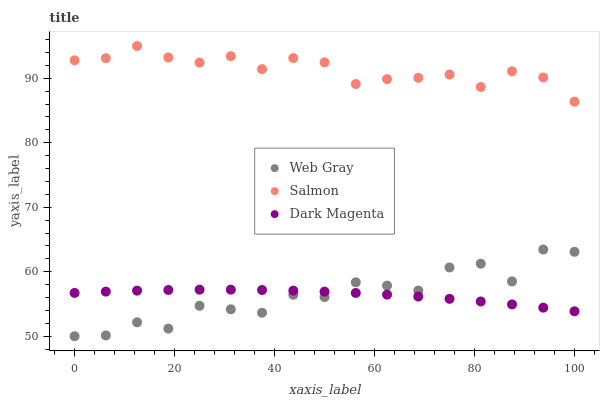Does Dark Magenta have the minimum area under the curve?
Answer yes or no. Yes. Does Salmon have the maximum area under the curve?
Answer yes or no. Yes. Does Salmon have the minimum area under the curve?
Answer yes or no. No. Does Dark Magenta have the maximum area under the curve?
Answer yes or no. No. Is Dark Magenta the smoothest?
Answer yes or no. Yes. Is Web Gray the roughest?
Answer yes or no. Yes. Is Salmon the smoothest?
Answer yes or no. No. Is Salmon the roughest?
Answer yes or no. No. Does Web Gray have the lowest value?
Answer yes or no. Yes. Does Dark Magenta have the lowest value?
Answer yes or no. No. Does Salmon have the highest value?
Answer yes or no. Yes. Does Dark Magenta have the highest value?
Answer yes or no. No. Is Web Gray less than Salmon?
Answer yes or no. Yes. Is Salmon greater than Web Gray?
Answer yes or no. Yes. Does Dark Magenta intersect Web Gray?
Answer yes or no. Yes. Is Dark Magenta less than Web Gray?
Answer yes or no. No. Is Dark Magenta greater than Web Gray?
Answer yes or no. No. Does Web Gray intersect Salmon?
Answer yes or no. No. 